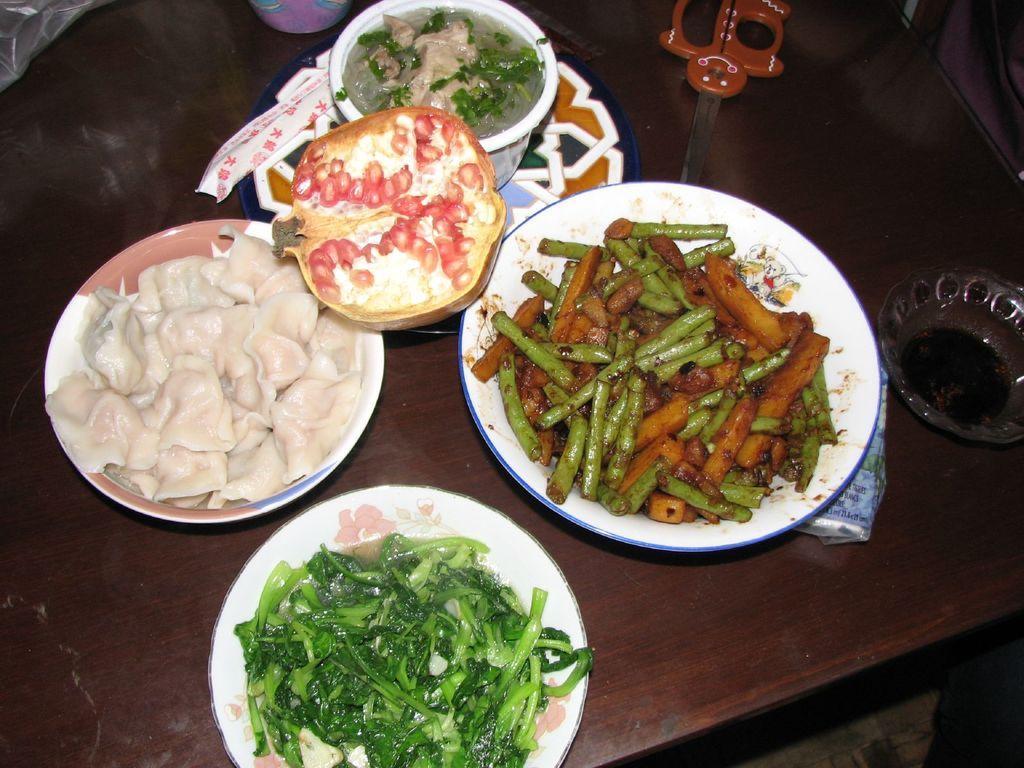Please provide a concise description of this image. In this picture we can see plates with food items in it, bowls, scissor and some objects on the wooden surface. 